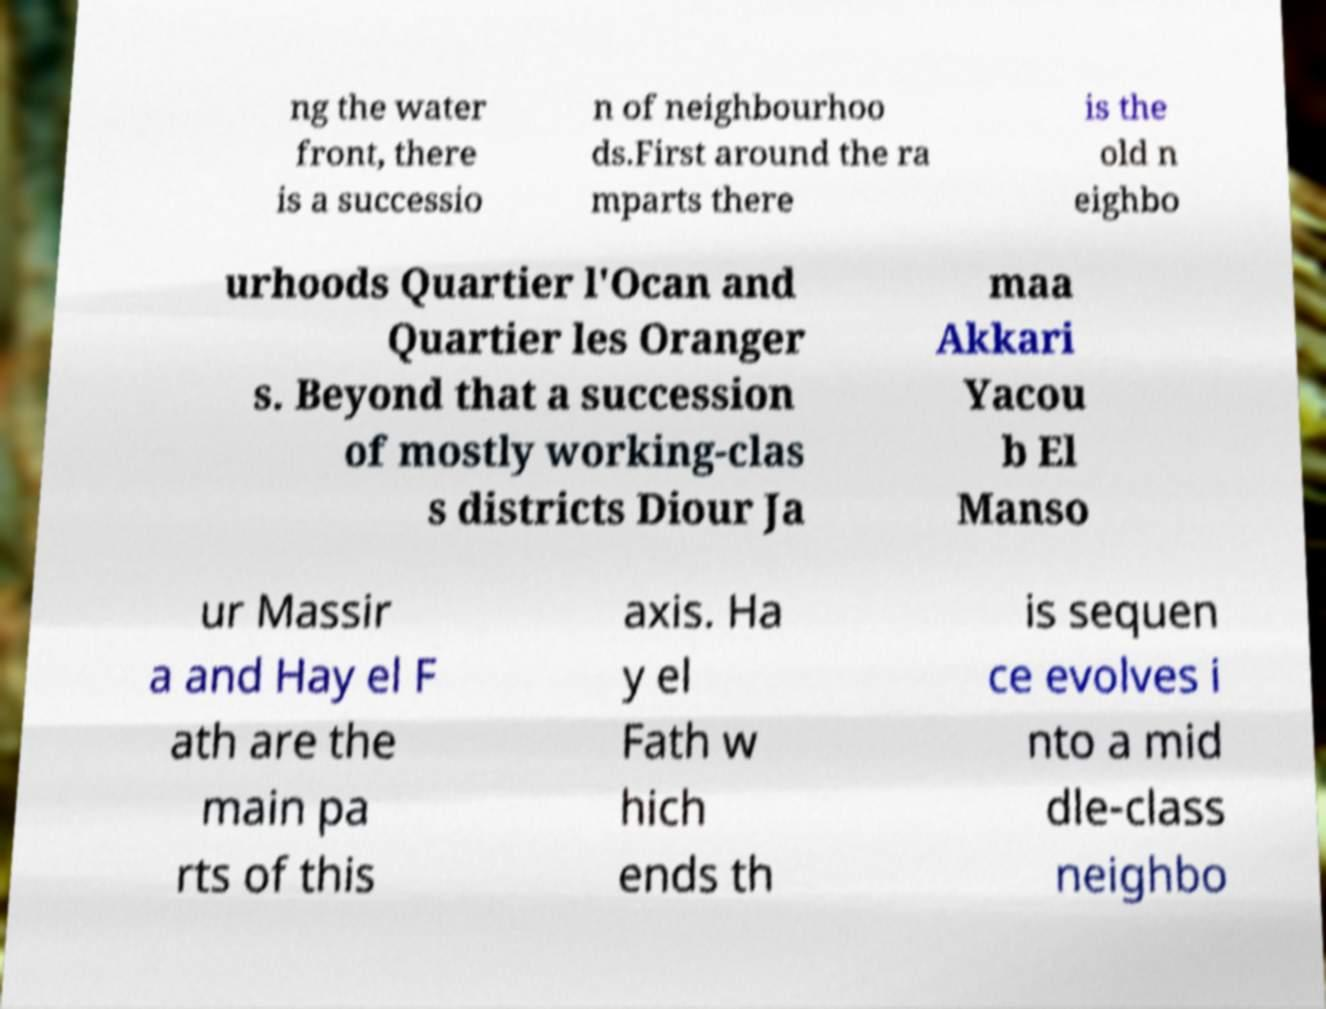There's text embedded in this image that I need extracted. Can you transcribe it verbatim? ng the water front, there is a successio n of neighbourhoo ds.First around the ra mparts there is the old n eighbo urhoods Quartier l'Ocan and Quartier les Oranger s. Beyond that a succession of mostly working-clas s districts Diour Ja maa Akkari Yacou b El Manso ur Massir a and Hay el F ath are the main pa rts of this axis. Ha y el Fath w hich ends th is sequen ce evolves i nto a mid dle-class neighbo 